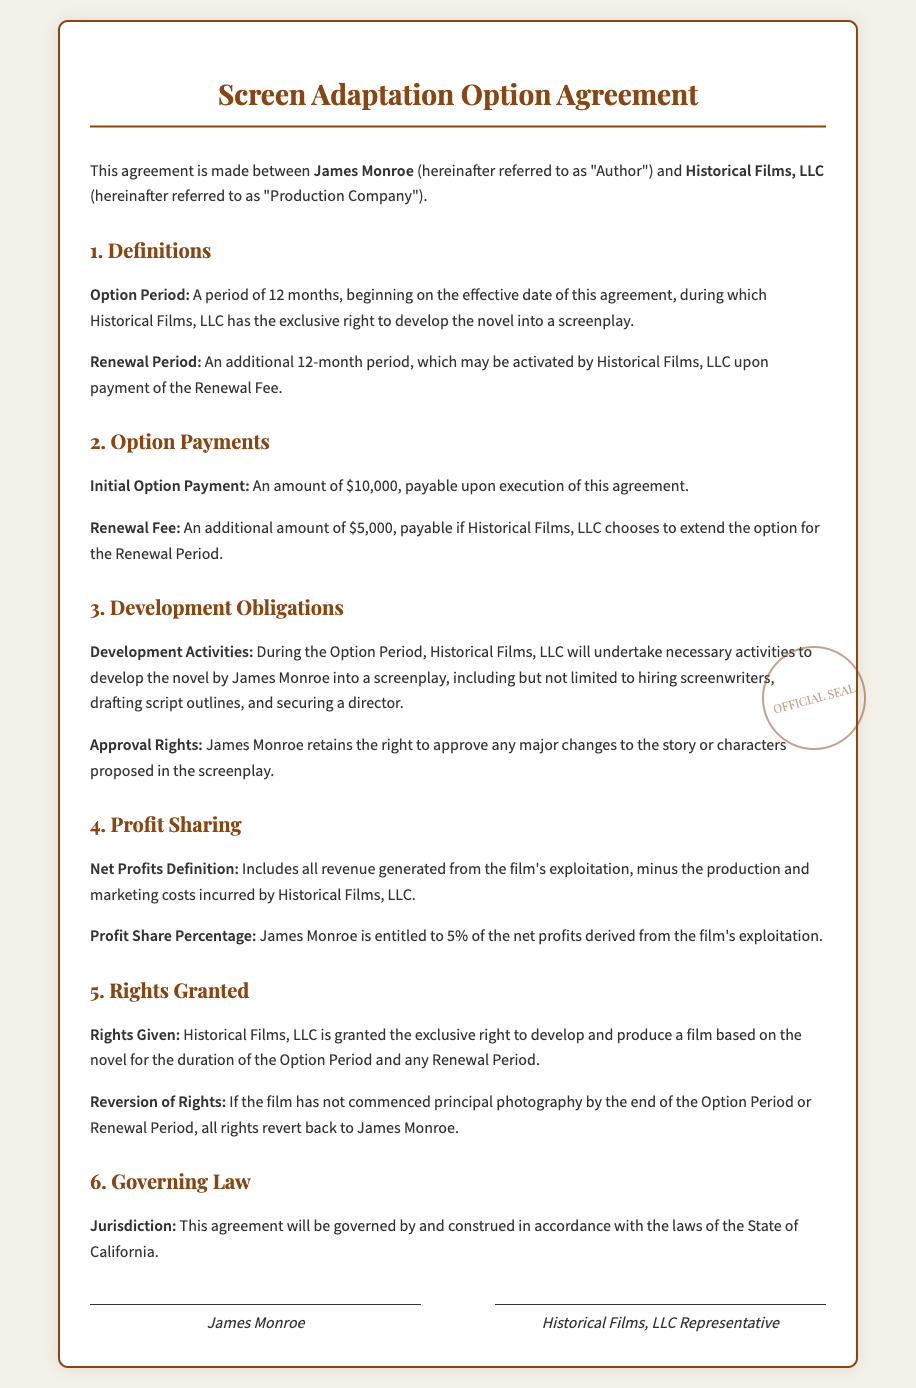What is the Initial Option Payment? The Initial Option Payment is specified in the document as the amount payable upon execution of the agreement.
Answer: $10,000 How long is the Option Period? The Option Period is defined in the document, indicating how long it lasts.
Answer: 12 months What percentage of the net profits does James Monroe receive? The document specifies the percentage of net profits entitled to James Monroe.
Answer: 5% What is the Renewal Fee amount? The document states the amount required if the Production Company chooses to extend the option.
Answer: $5,000 What happens if principal photography has not started by the end of the Option Period? The document outlines the condition under which rights revert back to the Author.
Answer: Rights revert back to James Monroe Who retains approval rights for major changes in the screenplay? The document mentions the party that retains rights related to story or character changes.
Answer: James Monroe Which state's laws govern this agreement? The document specifies the jurisdiction under which the agreement is governed.
Answer: California What entity is referred to as the Production Company? The document identifies the organization involved in the contract.
Answer: Historical Films, LLC 